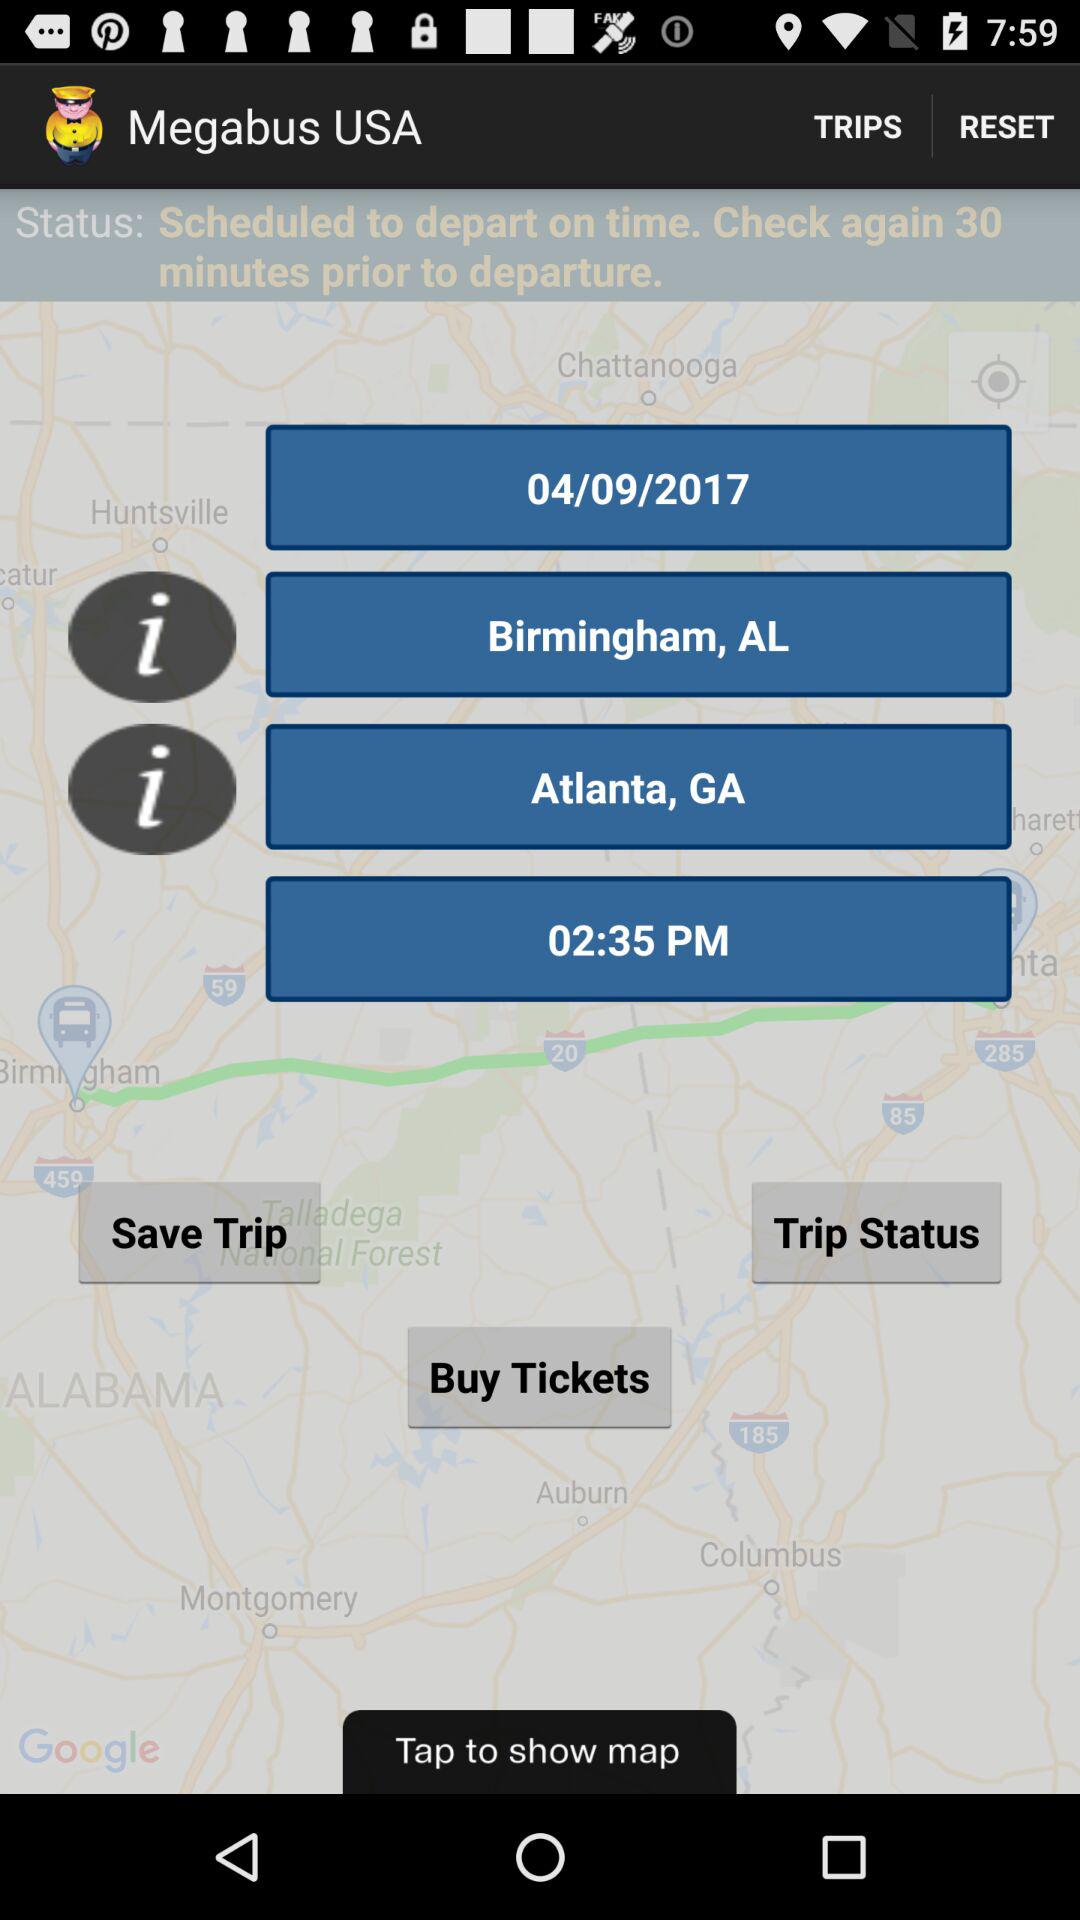What's the shown time? The shown time is 02:35 PM. 